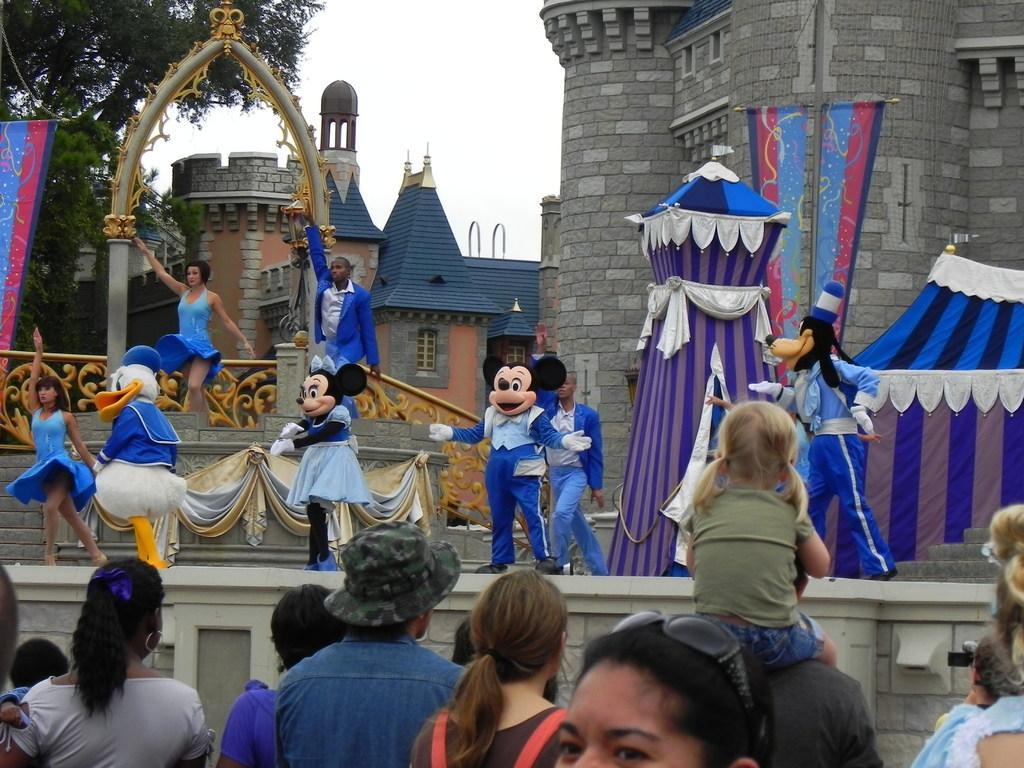Can you describe this image briefly? In this image I can see number of persons standing, the stage, few persons wearing costumes on the stage, few clothes, few buildings and few trees. In the background I can see the sky. 